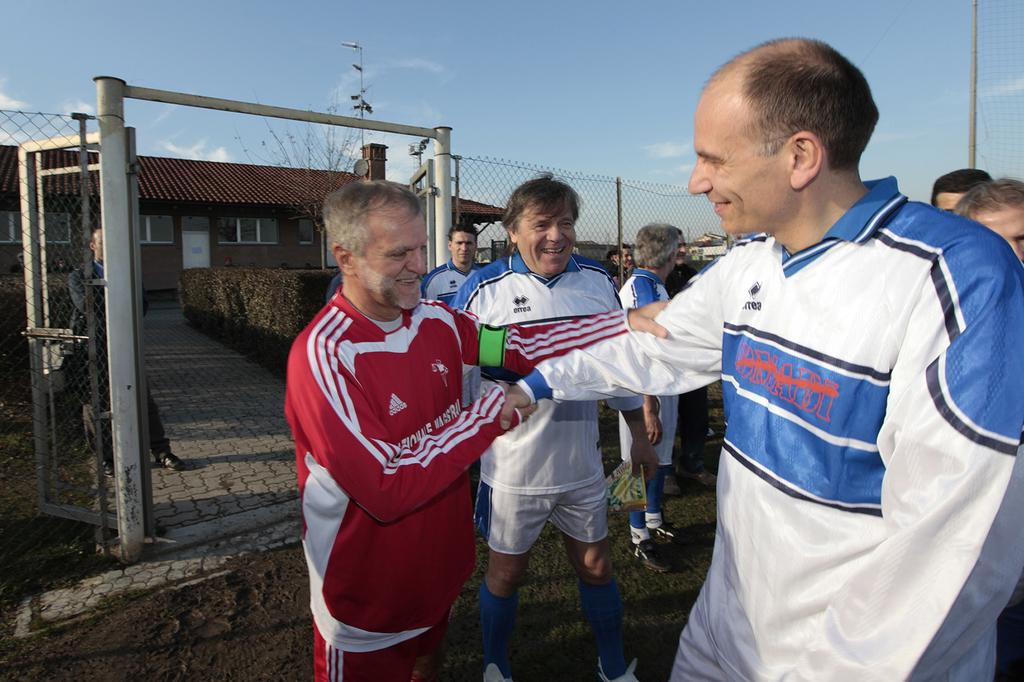<image>
Render a clear and concise summary of the photo. The brand of the red and white jacket is ADIDAS. 